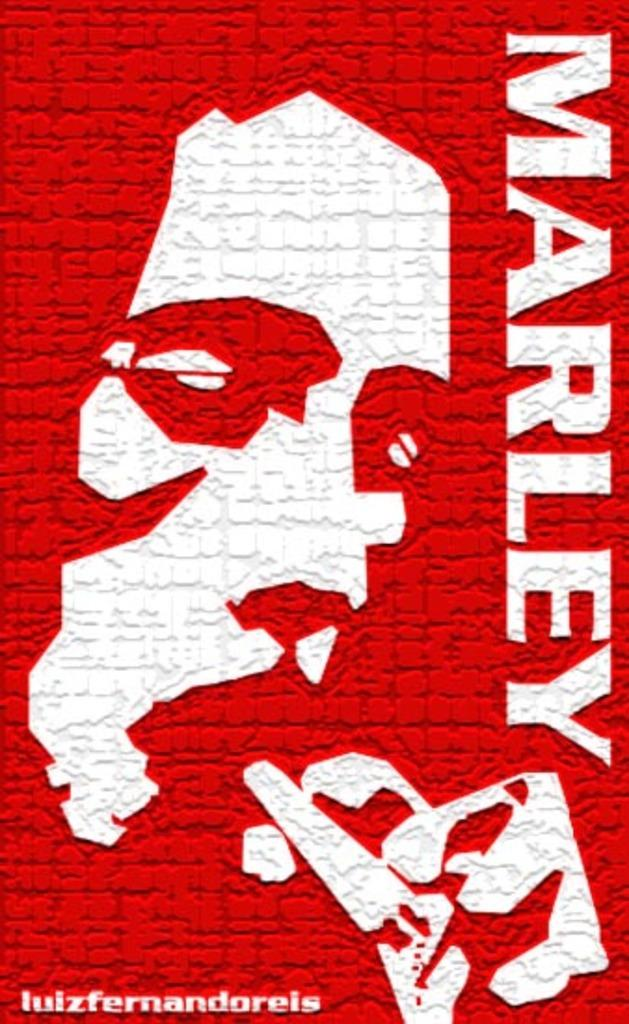Provide a one-sentence caption for the provided image. A Bob Marley poster with an outline of Bob's face. 